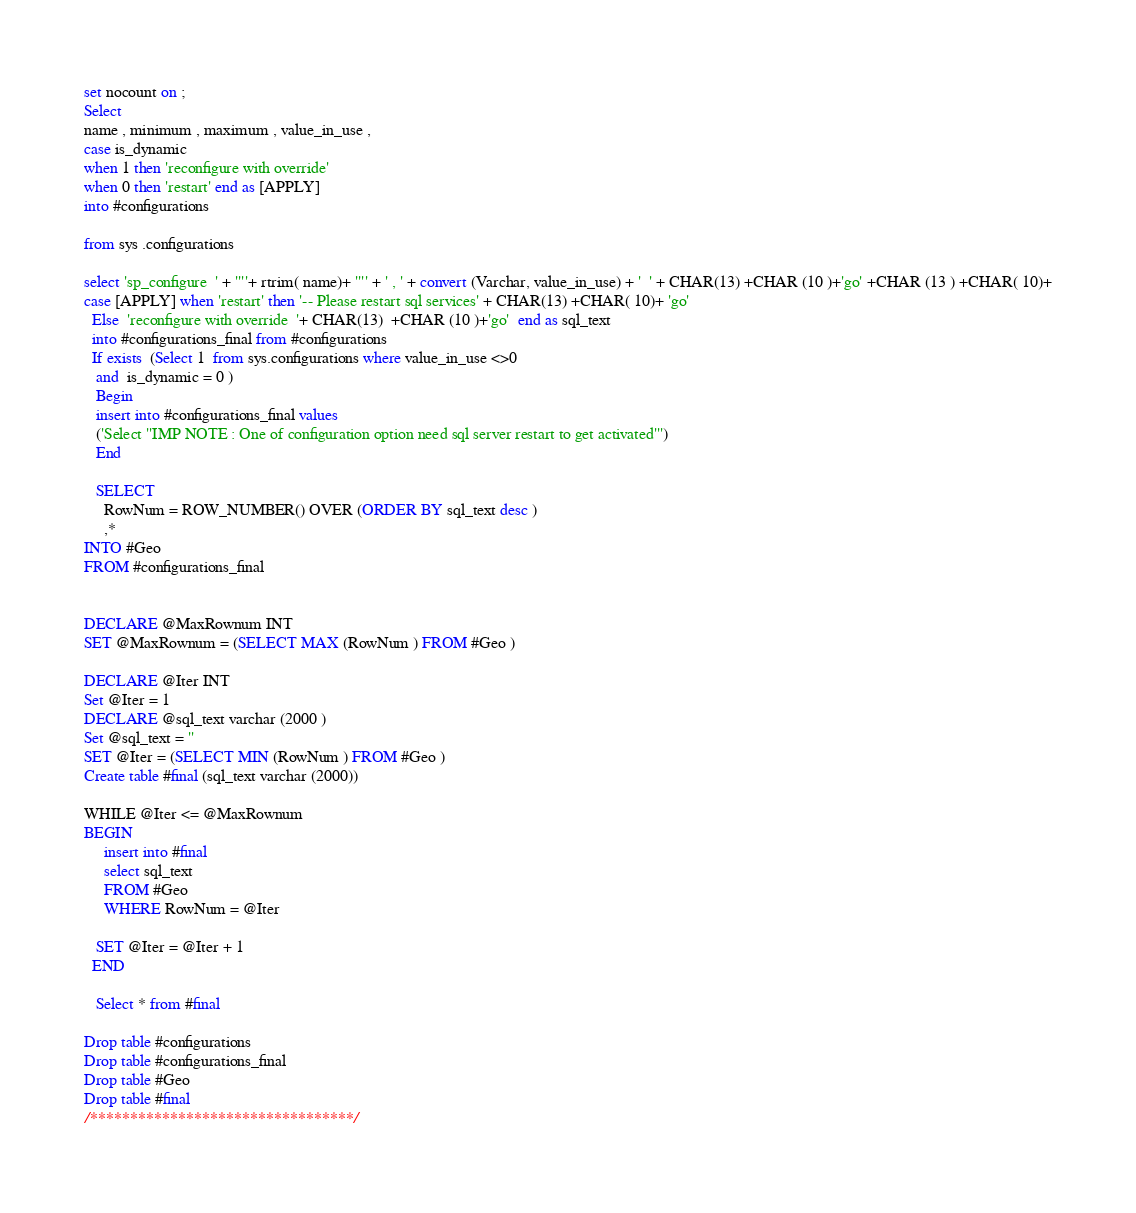Convert code to text. <code><loc_0><loc_0><loc_500><loc_500><_SQL_>set nocount on ;
Select 
name , minimum , maximum , value_in_use ,
case is_dynamic
when 1 then 'reconfigure with override'
when 0 then 'restart' end as [APPLY]
into #configurations

from sys .configurations 

select 'sp_configure  ' + ''''+ rtrim( name)+ '''' + ' , ' + convert (Varchar, value_in_use) + '  ' + CHAR(13) +CHAR (10 )+'go' +CHAR (13 ) +CHAR( 10)+
case [APPLY] when 'restart' then '-- Please restart sql services' + CHAR(13) +CHAR( 10)+ 'go'
  Else  'reconfigure with override  '+ CHAR(13)  +CHAR (10 )+'go'  end as sql_text
  into #configurations_final from #configurations
  If exists  (Select 1  from sys.configurations where value_in_use <>0
   and  is_dynamic = 0 )
   Begin
   insert into #configurations_final values
   ('Select ''IMP NOTE : One of configuration option need sql server restart to get activated''')
   End

   SELECT
     RowNum = ROW_NUMBER() OVER (ORDER BY sql_text desc )
     ,*
INTO #Geo
FROM #configurations_final


DECLARE @MaxRownum INT
SET @MaxRownum = (SELECT MAX (RowNum ) FROM #Geo )

DECLARE @Iter INT
Set @Iter = 1
DECLARE @sql_text varchar (2000 )
Set @sql_text = ''
SET @Iter = (SELECT MIN (RowNum ) FROM #Geo )
Create table #final (sql_text varchar (2000))

WHILE @Iter <= @MaxRownum
BEGIN
     insert into #final 
     select sql_text
     FROM #Geo
     WHERE RowNum = @Iter

   SET @Iter = @Iter + 1
  END

   Select * from #final

Drop table #configurations
Drop table #configurations_final
Drop table #Geo
Drop table #final
/*********************************/
</code> 